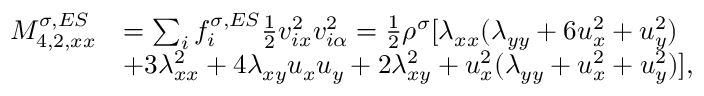<formula> <loc_0><loc_0><loc_500><loc_500>\begin{array} { r } { \begin{array} { r l } { M _ { 4 , 2 , x x } ^ { \sigma , E S } } & { = \sum _ { i } f _ { i } ^ { \sigma , E S } \frac { 1 } { 2 } v _ { i x } ^ { 2 } v _ { i \alpha } ^ { 2 } = \frac { 1 } { 2 } \rho ^ { \sigma } [ \lambda _ { x x } ( \lambda _ { y y } + 6 u _ { x } ^ { 2 } + u _ { y } ^ { 2 } ) } \\ & { + 3 \lambda _ { x x } ^ { 2 } + 4 \lambda _ { x y } u _ { x } u _ { y } + 2 \lambda _ { x y } ^ { 2 } + u _ { x } ^ { 2 } ( \lambda _ { y y } + u _ { x } ^ { 2 } + u _ { y } ^ { 2 } ) ] , } \end{array} } \end{array}</formula> 